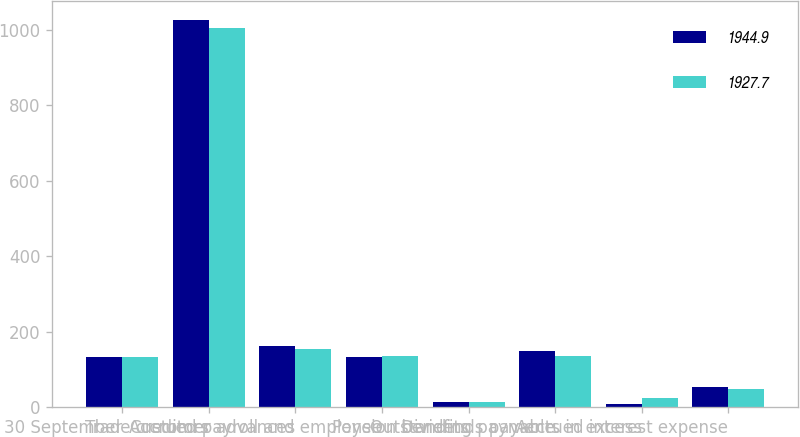Convert chart to OTSL. <chart><loc_0><loc_0><loc_500><loc_500><stacked_bar_chart><ecel><fcel>30 September<fcel>Trade creditors<fcel>Customer advances<fcel>Accrued payroll and employee<fcel>Pension benefits<fcel>Dividends payable<fcel>Outstanding payments in excess<fcel>Accrued interest expense<nl><fcel>1944.9<fcel>134.75<fcel>1025.5<fcel>162.7<fcel>133.5<fcel>14.7<fcel>150<fcel>10.5<fcel>54.1<nl><fcel>1927.7<fcel>134.75<fcel>1004.9<fcel>155<fcel>137.7<fcel>13.5<fcel>136<fcel>26.3<fcel>48.4<nl></chart> 